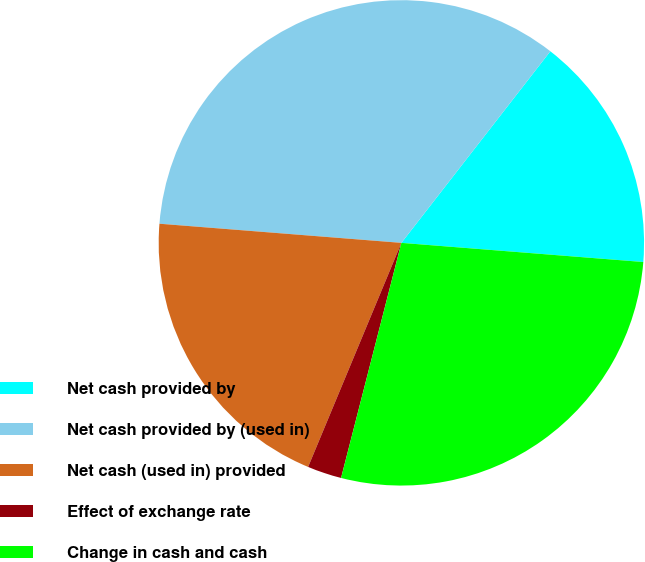Convert chart to OTSL. <chart><loc_0><loc_0><loc_500><loc_500><pie_chart><fcel>Net cash provided by<fcel>Net cash provided by (used in)<fcel>Net cash (used in) provided<fcel>Effect of exchange rate<fcel>Change in cash and cash<nl><fcel>15.74%<fcel>34.26%<fcel>19.98%<fcel>2.28%<fcel>27.74%<nl></chart> 